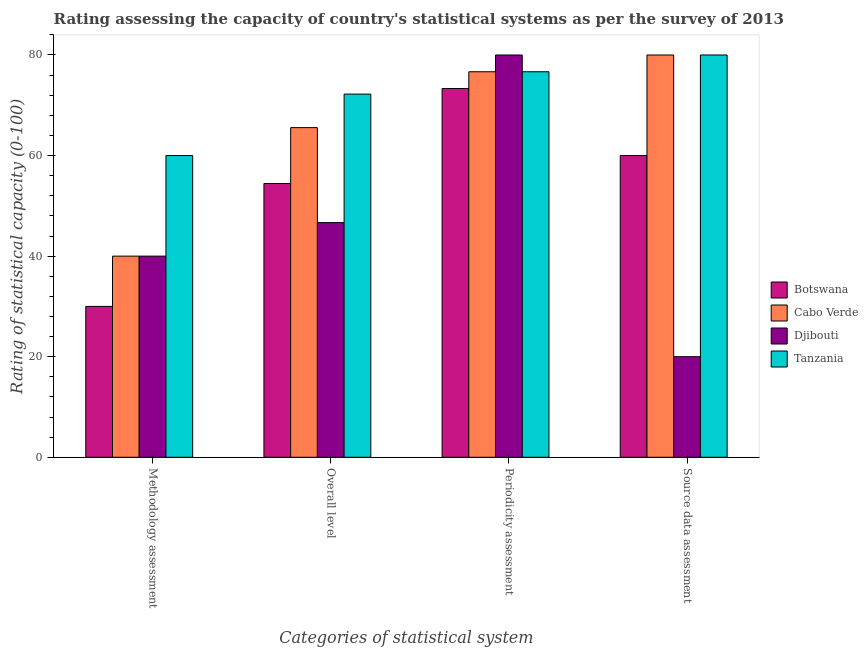How many different coloured bars are there?
Ensure brevity in your answer.  4. How many groups of bars are there?
Your response must be concise. 4. How many bars are there on the 2nd tick from the left?
Give a very brief answer. 4. What is the label of the 3rd group of bars from the left?
Make the answer very short. Periodicity assessment. What is the periodicity assessment rating in Botswana?
Your answer should be very brief. 73.33. Across all countries, what is the maximum overall level rating?
Offer a very short reply. 72.22. Across all countries, what is the minimum source data assessment rating?
Offer a terse response. 20. In which country was the methodology assessment rating maximum?
Offer a very short reply. Tanzania. In which country was the periodicity assessment rating minimum?
Ensure brevity in your answer.  Botswana. What is the total overall level rating in the graph?
Give a very brief answer. 238.89. What is the difference between the periodicity assessment rating in Botswana and that in Djibouti?
Offer a terse response. -6.67. What is the difference between the periodicity assessment rating in Tanzania and the methodology assessment rating in Cabo Verde?
Make the answer very short. 36.67. What is the average source data assessment rating per country?
Ensure brevity in your answer.  60. What is the difference between the overall level rating and methodology assessment rating in Tanzania?
Offer a very short reply. 12.22. In how many countries, is the periodicity assessment rating greater than 24 ?
Your answer should be compact. 4. What is the difference between the highest and the second highest methodology assessment rating?
Give a very brief answer. 20. What is the difference between the highest and the lowest periodicity assessment rating?
Your answer should be very brief. 6.67. Is the sum of the overall level rating in Djibouti and Tanzania greater than the maximum periodicity assessment rating across all countries?
Provide a succinct answer. Yes. What does the 4th bar from the left in Methodology assessment represents?
Your answer should be very brief. Tanzania. What does the 4th bar from the right in Methodology assessment represents?
Keep it short and to the point. Botswana. Is it the case that in every country, the sum of the methodology assessment rating and overall level rating is greater than the periodicity assessment rating?
Make the answer very short. Yes. How many bars are there?
Your answer should be very brief. 16. How many countries are there in the graph?
Offer a very short reply. 4. Does the graph contain any zero values?
Provide a short and direct response. No. How are the legend labels stacked?
Keep it short and to the point. Vertical. What is the title of the graph?
Offer a terse response. Rating assessing the capacity of country's statistical systems as per the survey of 2013 . Does "India" appear as one of the legend labels in the graph?
Offer a terse response. No. What is the label or title of the X-axis?
Your response must be concise. Categories of statistical system. What is the label or title of the Y-axis?
Make the answer very short. Rating of statistical capacity (0-100). What is the Rating of statistical capacity (0-100) in Djibouti in Methodology assessment?
Give a very brief answer. 40. What is the Rating of statistical capacity (0-100) of Botswana in Overall level?
Offer a terse response. 54.44. What is the Rating of statistical capacity (0-100) of Cabo Verde in Overall level?
Ensure brevity in your answer.  65.56. What is the Rating of statistical capacity (0-100) of Djibouti in Overall level?
Your answer should be compact. 46.67. What is the Rating of statistical capacity (0-100) of Tanzania in Overall level?
Your answer should be compact. 72.22. What is the Rating of statistical capacity (0-100) in Botswana in Periodicity assessment?
Offer a very short reply. 73.33. What is the Rating of statistical capacity (0-100) of Cabo Verde in Periodicity assessment?
Provide a succinct answer. 76.67. What is the Rating of statistical capacity (0-100) in Tanzania in Periodicity assessment?
Make the answer very short. 76.67. What is the Rating of statistical capacity (0-100) of Botswana in Source data assessment?
Ensure brevity in your answer.  60. What is the Rating of statistical capacity (0-100) of Djibouti in Source data assessment?
Your response must be concise. 20. What is the Rating of statistical capacity (0-100) of Tanzania in Source data assessment?
Provide a short and direct response. 80. Across all Categories of statistical system, what is the maximum Rating of statistical capacity (0-100) of Botswana?
Provide a short and direct response. 73.33. Across all Categories of statistical system, what is the maximum Rating of statistical capacity (0-100) of Cabo Verde?
Keep it short and to the point. 80. Across all Categories of statistical system, what is the maximum Rating of statistical capacity (0-100) in Tanzania?
Offer a terse response. 80. Across all Categories of statistical system, what is the minimum Rating of statistical capacity (0-100) of Botswana?
Keep it short and to the point. 30. Across all Categories of statistical system, what is the minimum Rating of statistical capacity (0-100) in Cabo Verde?
Provide a succinct answer. 40. What is the total Rating of statistical capacity (0-100) of Botswana in the graph?
Keep it short and to the point. 217.78. What is the total Rating of statistical capacity (0-100) in Cabo Verde in the graph?
Offer a very short reply. 262.22. What is the total Rating of statistical capacity (0-100) in Djibouti in the graph?
Provide a succinct answer. 186.67. What is the total Rating of statistical capacity (0-100) in Tanzania in the graph?
Keep it short and to the point. 288.89. What is the difference between the Rating of statistical capacity (0-100) of Botswana in Methodology assessment and that in Overall level?
Your response must be concise. -24.44. What is the difference between the Rating of statistical capacity (0-100) in Cabo Verde in Methodology assessment and that in Overall level?
Your response must be concise. -25.56. What is the difference between the Rating of statistical capacity (0-100) in Djibouti in Methodology assessment and that in Overall level?
Provide a short and direct response. -6.67. What is the difference between the Rating of statistical capacity (0-100) of Tanzania in Methodology assessment and that in Overall level?
Give a very brief answer. -12.22. What is the difference between the Rating of statistical capacity (0-100) in Botswana in Methodology assessment and that in Periodicity assessment?
Ensure brevity in your answer.  -43.33. What is the difference between the Rating of statistical capacity (0-100) in Cabo Verde in Methodology assessment and that in Periodicity assessment?
Provide a short and direct response. -36.67. What is the difference between the Rating of statistical capacity (0-100) of Djibouti in Methodology assessment and that in Periodicity assessment?
Your response must be concise. -40. What is the difference between the Rating of statistical capacity (0-100) of Tanzania in Methodology assessment and that in Periodicity assessment?
Your answer should be very brief. -16.67. What is the difference between the Rating of statistical capacity (0-100) of Botswana in Methodology assessment and that in Source data assessment?
Your answer should be very brief. -30. What is the difference between the Rating of statistical capacity (0-100) of Cabo Verde in Methodology assessment and that in Source data assessment?
Provide a succinct answer. -40. What is the difference between the Rating of statistical capacity (0-100) in Tanzania in Methodology assessment and that in Source data assessment?
Offer a terse response. -20. What is the difference between the Rating of statistical capacity (0-100) in Botswana in Overall level and that in Periodicity assessment?
Provide a short and direct response. -18.89. What is the difference between the Rating of statistical capacity (0-100) of Cabo Verde in Overall level and that in Periodicity assessment?
Your answer should be very brief. -11.11. What is the difference between the Rating of statistical capacity (0-100) of Djibouti in Overall level and that in Periodicity assessment?
Provide a succinct answer. -33.33. What is the difference between the Rating of statistical capacity (0-100) of Tanzania in Overall level and that in Periodicity assessment?
Ensure brevity in your answer.  -4.44. What is the difference between the Rating of statistical capacity (0-100) of Botswana in Overall level and that in Source data assessment?
Make the answer very short. -5.56. What is the difference between the Rating of statistical capacity (0-100) in Cabo Verde in Overall level and that in Source data assessment?
Provide a succinct answer. -14.44. What is the difference between the Rating of statistical capacity (0-100) in Djibouti in Overall level and that in Source data assessment?
Your answer should be very brief. 26.67. What is the difference between the Rating of statistical capacity (0-100) of Tanzania in Overall level and that in Source data assessment?
Make the answer very short. -7.78. What is the difference between the Rating of statistical capacity (0-100) in Botswana in Periodicity assessment and that in Source data assessment?
Provide a succinct answer. 13.33. What is the difference between the Rating of statistical capacity (0-100) in Djibouti in Periodicity assessment and that in Source data assessment?
Keep it short and to the point. 60. What is the difference between the Rating of statistical capacity (0-100) in Tanzania in Periodicity assessment and that in Source data assessment?
Give a very brief answer. -3.33. What is the difference between the Rating of statistical capacity (0-100) in Botswana in Methodology assessment and the Rating of statistical capacity (0-100) in Cabo Verde in Overall level?
Provide a short and direct response. -35.56. What is the difference between the Rating of statistical capacity (0-100) of Botswana in Methodology assessment and the Rating of statistical capacity (0-100) of Djibouti in Overall level?
Your response must be concise. -16.67. What is the difference between the Rating of statistical capacity (0-100) in Botswana in Methodology assessment and the Rating of statistical capacity (0-100) in Tanzania in Overall level?
Make the answer very short. -42.22. What is the difference between the Rating of statistical capacity (0-100) of Cabo Verde in Methodology assessment and the Rating of statistical capacity (0-100) of Djibouti in Overall level?
Keep it short and to the point. -6.67. What is the difference between the Rating of statistical capacity (0-100) in Cabo Verde in Methodology assessment and the Rating of statistical capacity (0-100) in Tanzania in Overall level?
Give a very brief answer. -32.22. What is the difference between the Rating of statistical capacity (0-100) in Djibouti in Methodology assessment and the Rating of statistical capacity (0-100) in Tanzania in Overall level?
Your response must be concise. -32.22. What is the difference between the Rating of statistical capacity (0-100) in Botswana in Methodology assessment and the Rating of statistical capacity (0-100) in Cabo Verde in Periodicity assessment?
Offer a very short reply. -46.67. What is the difference between the Rating of statistical capacity (0-100) in Botswana in Methodology assessment and the Rating of statistical capacity (0-100) in Djibouti in Periodicity assessment?
Your answer should be compact. -50. What is the difference between the Rating of statistical capacity (0-100) of Botswana in Methodology assessment and the Rating of statistical capacity (0-100) of Tanzania in Periodicity assessment?
Your response must be concise. -46.67. What is the difference between the Rating of statistical capacity (0-100) of Cabo Verde in Methodology assessment and the Rating of statistical capacity (0-100) of Tanzania in Periodicity assessment?
Make the answer very short. -36.67. What is the difference between the Rating of statistical capacity (0-100) of Djibouti in Methodology assessment and the Rating of statistical capacity (0-100) of Tanzania in Periodicity assessment?
Provide a short and direct response. -36.67. What is the difference between the Rating of statistical capacity (0-100) in Botswana in Methodology assessment and the Rating of statistical capacity (0-100) in Djibouti in Source data assessment?
Your answer should be very brief. 10. What is the difference between the Rating of statistical capacity (0-100) in Cabo Verde in Methodology assessment and the Rating of statistical capacity (0-100) in Djibouti in Source data assessment?
Keep it short and to the point. 20. What is the difference between the Rating of statistical capacity (0-100) of Cabo Verde in Methodology assessment and the Rating of statistical capacity (0-100) of Tanzania in Source data assessment?
Make the answer very short. -40. What is the difference between the Rating of statistical capacity (0-100) of Djibouti in Methodology assessment and the Rating of statistical capacity (0-100) of Tanzania in Source data assessment?
Your answer should be very brief. -40. What is the difference between the Rating of statistical capacity (0-100) in Botswana in Overall level and the Rating of statistical capacity (0-100) in Cabo Verde in Periodicity assessment?
Offer a terse response. -22.22. What is the difference between the Rating of statistical capacity (0-100) of Botswana in Overall level and the Rating of statistical capacity (0-100) of Djibouti in Periodicity assessment?
Your response must be concise. -25.56. What is the difference between the Rating of statistical capacity (0-100) of Botswana in Overall level and the Rating of statistical capacity (0-100) of Tanzania in Periodicity assessment?
Keep it short and to the point. -22.22. What is the difference between the Rating of statistical capacity (0-100) in Cabo Verde in Overall level and the Rating of statistical capacity (0-100) in Djibouti in Periodicity assessment?
Provide a short and direct response. -14.44. What is the difference between the Rating of statistical capacity (0-100) of Cabo Verde in Overall level and the Rating of statistical capacity (0-100) of Tanzania in Periodicity assessment?
Give a very brief answer. -11.11. What is the difference between the Rating of statistical capacity (0-100) in Djibouti in Overall level and the Rating of statistical capacity (0-100) in Tanzania in Periodicity assessment?
Provide a short and direct response. -30. What is the difference between the Rating of statistical capacity (0-100) in Botswana in Overall level and the Rating of statistical capacity (0-100) in Cabo Verde in Source data assessment?
Your answer should be very brief. -25.56. What is the difference between the Rating of statistical capacity (0-100) of Botswana in Overall level and the Rating of statistical capacity (0-100) of Djibouti in Source data assessment?
Offer a very short reply. 34.44. What is the difference between the Rating of statistical capacity (0-100) of Botswana in Overall level and the Rating of statistical capacity (0-100) of Tanzania in Source data assessment?
Give a very brief answer. -25.56. What is the difference between the Rating of statistical capacity (0-100) of Cabo Verde in Overall level and the Rating of statistical capacity (0-100) of Djibouti in Source data assessment?
Provide a short and direct response. 45.56. What is the difference between the Rating of statistical capacity (0-100) of Cabo Verde in Overall level and the Rating of statistical capacity (0-100) of Tanzania in Source data assessment?
Your answer should be compact. -14.44. What is the difference between the Rating of statistical capacity (0-100) of Djibouti in Overall level and the Rating of statistical capacity (0-100) of Tanzania in Source data assessment?
Provide a succinct answer. -33.33. What is the difference between the Rating of statistical capacity (0-100) of Botswana in Periodicity assessment and the Rating of statistical capacity (0-100) of Cabo Verde in Source data assessment?
Your answer should be very brief. -6.67. What is the difference between the Rating of statistical capacity (0-100) of Botswana in Periodicity assessment and the Rating of statistical capacity (0-100) of Djibouti in Source data assessment?
Keep it short and to the point. 53.33. What is the difference between the Rating of statistical capacity (0-100) of Botswana in Periodicity assessment and the Rating of statistical capacity (0-100) of Tanzania in Source data assessment?
Give a very brief answer. -6.67. What is the difference between the Rating of statistical capacity (0-100) in Cabo Verde in Periodicity assessment and the Rating of statistical capacity (0-100) in Djibouti in Source data assessment?
Ensure brevity in your answer.  56.67. What is the average Rating of statistical capacity (0-100) in Botswana per Categories of statistical system?
Provide a short and direct response. 54.44. What is the average Rating of statistical capacity (0-100) in Cabo Verde per Categories of statistical system?
Ensure brevity in your answer.  65.56. What is the average Rating of statistical capacity (0-100) in Djibouti per Categories of statistical system?
Give a very brief answer. 46.67. What is the average Rating of statistical capacity (0-100) in Tanzania per Categories of statistical system?
Make the answer very short. 72.22. What is the difference between the Rating of statistical capacity (0-100) of Botswana and Rating of statistical capacity (0-100) of Tanzania in Methodology assessment?
Provide a succinct answer. -30. What is the difference between the Rating of statistical capacity (0-100) of Cabo Verde and Rating of statistical capacity (0-100) of Tanzania in Methodology assessment?
Provide a short and direct response. -20. What is the difference between the Rating of statistical capacity (0-100) of Botswana and Rating of statistical capacity (0-100) of Cabo Verde in Overall level?
Provide a short and direct response. -11.11. What is the difference between the Rating of statistical capacity (0-100) in Botswana and Rating of statistical capacity (0-100) in Djibouti in Overall level?
Your response must be concise. 7.78. What is the difference between the Rating of statistical capacity (0-100) of Botswana and Rating of statistical capacity (0-100) of Tanzania in Overall level?
Give a very brief answer. -17.78. What is the difference between the Rating of statistical capacity (0-100) of Cabo Verde and Rating of statistical capacity (0-100) of Djibouti in Overall level?
Your answer should be compact. 18.89. What is the difference between the Rating of statistical capacity (0-100) in Cabo Verde and Rating of statistical capacity (0-100) in Tanzania in Overall level?
Offer a terse response. -6.67. What is the difference between the Rating of statistical capacity (0-100) of Djibouti and Rating of statistical capacity (0-100) of Tanzania in Overall level?
Keep it short and to the point. -25.56. What is the difference between the Rating of statistical capacity (0-100) in Botswana and Rating of statistical capacity (0-100) in Djibouti in Periodicity assessment?
Provide a succinct answer. -6.67. What is the difference between the Rating of statistical capacity (0-100) in Botswana and Rating of statistical capacity (0-100) in Tanzania in Periodicity assessment?
Ensure brevity in your answer.  -3.33. What is the difference between the Rating of statistical capacity (0-100) in Cabo Verde and Rating of statistical capacity (0-100) in Djibouti in Periodicity assessment?
Your response must be concise. -3.33. What is the difference between the Rating of statistical capacity (0-100) in Djibouti and Rating of statistical capacity (0-100) in Tanzania in Periodicity assessment?
Your response must be concise. 3.33. What is the difference between the Rating of statistical capacity (0-100) of Botswana and Rating of statistical capacity (0-100) of Djibouti in Source data assessment?
Offer a terse response. 40. What is the difference between the Rating of statistical capacity (0-100) of Cabo Verde and Rating of statistical capacity (0-100) of Tanzania in Source data assessment?
Keep it short and to the point. 0. What is the difference between the Rating of statistical capacity (0-100) in Djibouti and Rating of statistical capacity (0-100) in Tanzania in Source data assessment?
Your answer should be very brief. -60. What is the ratio of the Rating of statistical capacity (0-100) in Botswana in Methodology assessment to that in Overall level?
Offer a very short reply. 0.55. What is the ratio of the Rating of statistical capacity (0-100) of Cabo Verde in Methodology assessment to that in Overall level?
Your answer should be very brief. 0.61. What is the ratio of the Rating of statistical capacity (0-100) of Tanzania in Methodology assessment to that in Overall level?
Your answer should be very brief. 0.83. What is the ratio of the Rating of statistical capacity (0-100) of Botswana in Methodology assessment to that in Periodicity assessment?
Make the answer very short. 0.41. What is the ratio of the Rating of statistical capacity (0-100) in Cabo Verde in Methodology assessment to that in Periodicity assessment?
Offer a very short reply. 0.52. What is the ratio of the Rating of statistical capacity (0-100) in Tanzania in Methodology assessment to that in Periodicity assessment?
Keep it short and to the point. 0.78. What is the ratio of the Rating of statistical capacity (0-100) of Botswana in Methodology assessment to that in Source data assessment?
Provide a succinct answer. 0.5. What is the ratio of the Rating of statistical capacity (0-100) of Cabo Verde in Methodology assessment to that in Source data assessment?
Provide a short and direct response. 0.5. What is the ratio of the Rating of statistical capacity (0-100) in Tanzania in Methodology assessment to that in Source data assessment?
Your answer should be compact. 0.75. What is the ratio of the Rating of statistical capacity (0-100) of Botswana in Overall level to that in Periodicity assessment?
Make the answer very short. 0.74. What is the ratio of the Rating of statistical capacity (0-100) in Cabo Verde in Overall level to that in Periodicity assessment?
Offer a terse response. 0.86. What is the ratio of the Rating of statistical capacity (0-100) in Djibouti in Overall level to that in Periodicity assessment?
Your response must be concise. 0.58. What is the ratio of the Rating of statistical capacity (0-100) in Tanzania in Overall level to that in Periodicity assessment?
Make the answer very short. 0.94. What is the ratio of the Rating of statistical capacity (0-100) in Botswana in Overall level to that in Source data assessment?
Your answer should be very brief. 0.91. What is the ratio of the Rating of statistical capacity (0-100) of Cabo Verde in Overall level to that in Source data assessment?
Your answer should be very brief. 0.82. What is the ratio of the Rating of statistical capacity (0-100) in Djibouti in Overall level to that in Source data assessment?
Your answer should be compact. 2.33. What is the ratio of the Rating of statistical capacity (0-100) in Tanzania in Overall level to that in Source data assessment?
Make the answer very short. 0.9. What is the ratio of the Rating of statistical capacity (0-100) of Botswana in Periodicity assessment to that in Source data assessment?
Keep it short and to the point. 1.22. What is the ratio of the Rating of statistical capacity (0-100) of Cabo Verde in Periodicity assessment to that in Source data assessment?
Offer a terse response. 0.96. What is the ratio of the Rating of statistical capacity (0-100) in Tanzania in Periodicity assessment to that in Source data assessment?
Provide a short and direct response. 0.96. What is the difference between the highest and the second highest Rating of statistical capacity (0-100) in Botswana?
Offer a very short reply. 13.33. What is the difference between the highest and the second highest Rating of statistical capacity (0-100) in Djibouti?
Offer a very short reply. 33.33. What is the difference between the highest and the lowest Rating of statistical capacity (0-100) of Botswana?
Your answer should be very brief. 43.33. What is the difference between the highest and the lowest Rating of statistical capacity (0-100) in Tanzania?
Give a very brief answer. 20. 